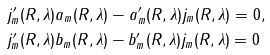<formula> <loc_0><loc_0><loc_500><loc_500>& j _ { m } ^ { \prime } ( R , \lambda ) a _ { m } ( R , \lambda ) - a _ { m } ^ { \prime } ( R , \lambda ) j _ { m } ( R , \lambda ) = 0 , \\ & j _ { m } ^ { \prime } ( R , \lambda ) b _ { m } ( R , \lambda ) - b _ { m } ^ { \prime } ( R , \lambda ) j _ { m } ( R , \lambda ) = 0</formula> 